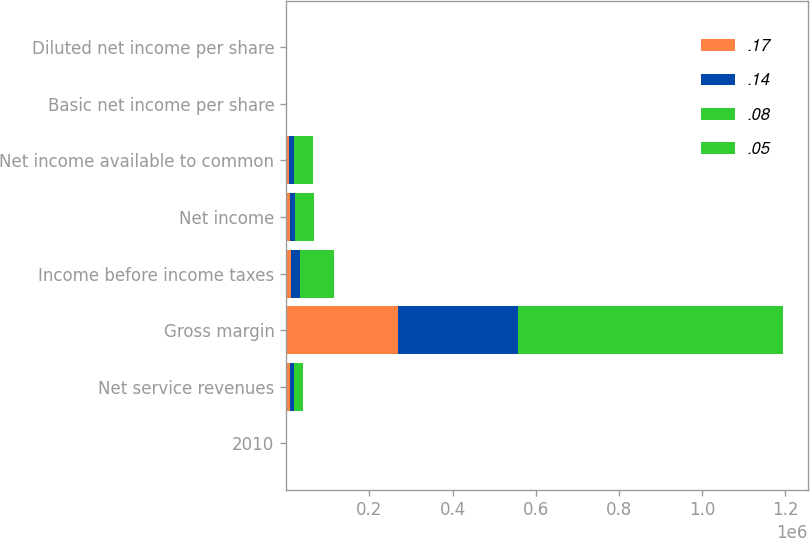<chart> <loc_0><loc_0><loc_500><loc_500><stacked_bar_chart><ecel><fcel>2010<fcel>Net service revenues<fcel>Gross margin<fcel>Income before income taxes<fcel>Net income<fcel>Net income available to common<fcel>Basic net income per share<fcel>Diluted net income per share<nl><fcel>0.17<fcel>1<fcel>10067.5<fcel>268128<fcel>12265<fcel>8475<fcel>7626<fcel>0.05<fcel>0.05<nl><fcel>0.14<fcel>2<fcel>10067.5<fcel>289858<fcel>22387<fcel>12181<fcel>11660<fcel>0.08<fcel>0.08<nl><fcel>0.08<fcel>3<fcel>10067.5<fcel>309140<fcel>37268<fcel>20623<fcel>20099<fcel>0.14<fcel>0.14<nl><fcel>0.05<fcel>4<fcel>10067.5<fcel>326907<fcel>43248<fcel>24790<fcel>24144<fcel>0.17<fcel>0.17<nl></chart> 